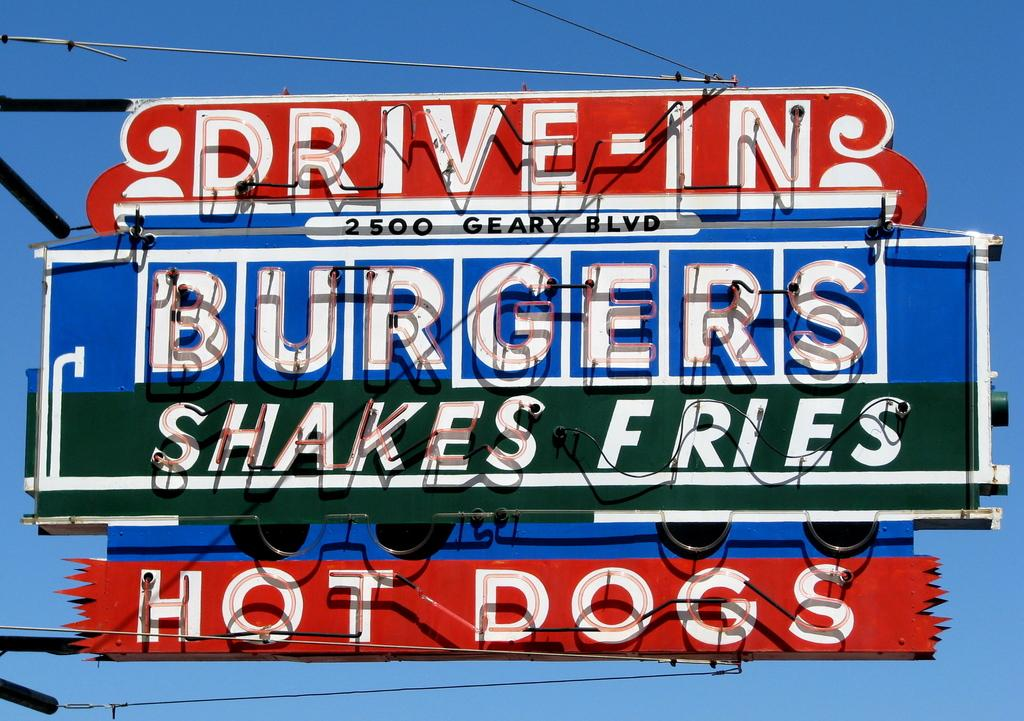<image>
Describe the image concisely. A sign that advertises a Drive In that served Burgers, shakes, and fries. 